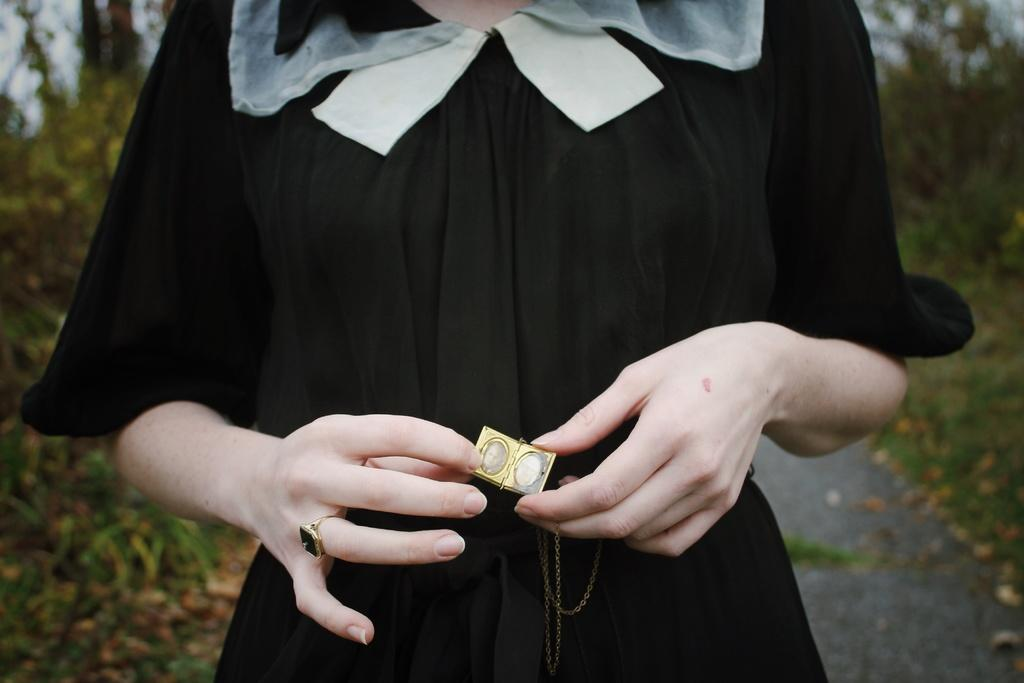Who is the main subject in the image? There is a woman in the image. What is the woman holding in her hands? The woman is holding a locket in her hands. What is the woman wearing? The woman is wearing a black dress. What can be seen in the background of the image? There are plants and trees in the background of the image. What type of bone can be seen in the woman's hand in the image? There is no bone present in the image; the woman is holding a locket in her hands. 